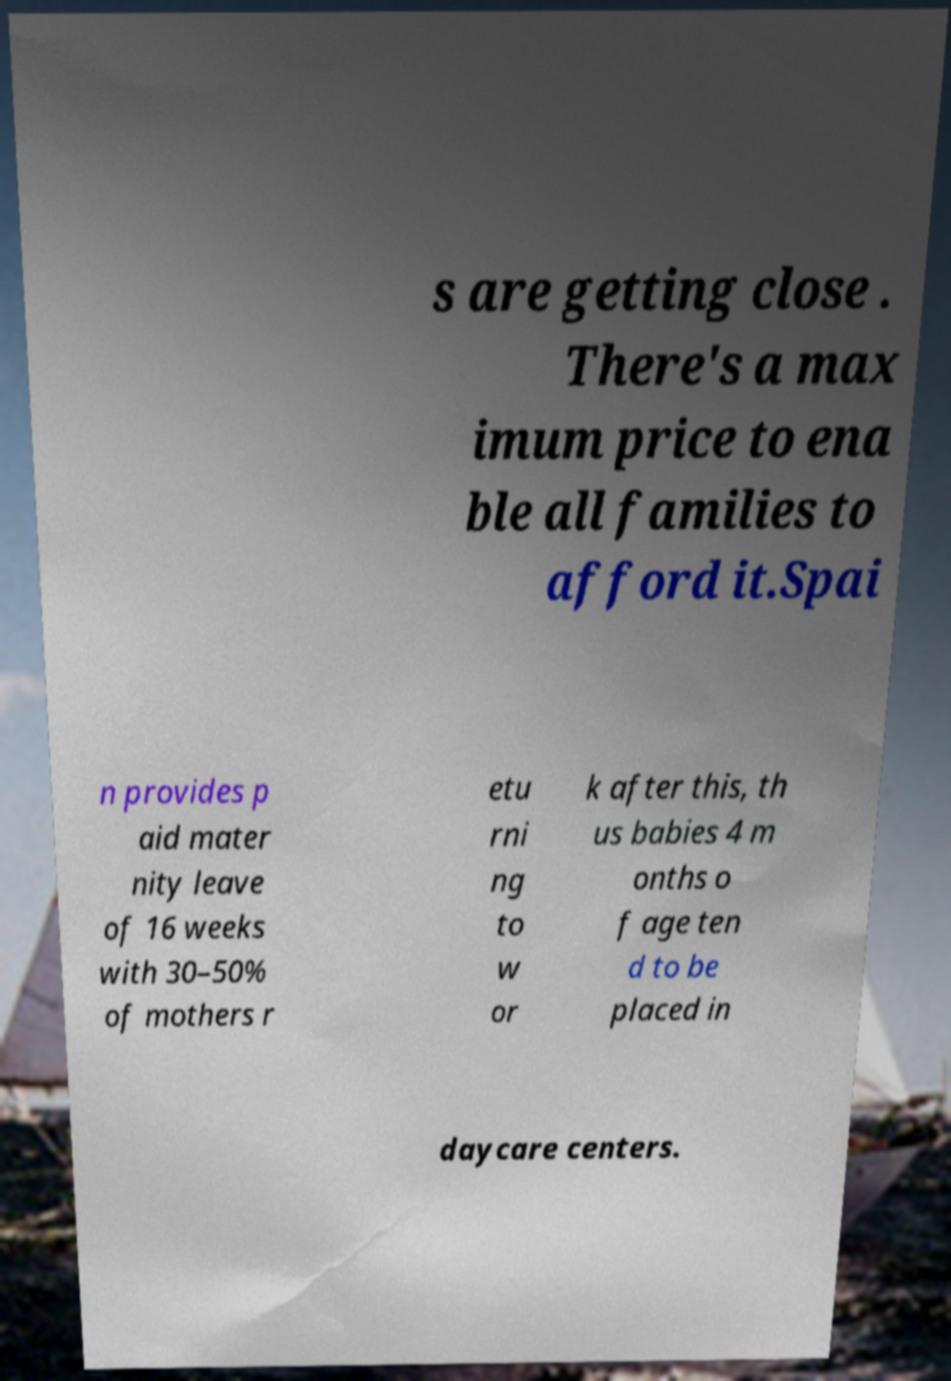Please read and relay the text visible in this image. What does it say? s are getting close . There's a max imum price to ena ble all families to afford it.Spai n provides p aid mater nity leave of 16 weeks with 30–50% of mothers r etu rni ng to w or k after this, th us babies 4 m onths o f age ten d to be placed in daycare centers. 